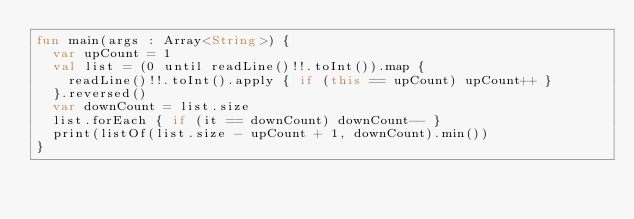Convert code to text. <code><loc_0><loc_0><loc_500><loc_500><_Kotlin_>fun main(args : Array<String>) {
  var upCount = 1
  val list = (0 until readLine()!!.toInt()).map {
    readLine()!!.toInt().apply { if (this == upCount) upCount++ }
  }.reversed()
  var downCount = list.size
  list.forEach { if (it == downCount) downCount-- }
  print(listOf(list.size - upCount + 1, downCount).min())
}</code> 